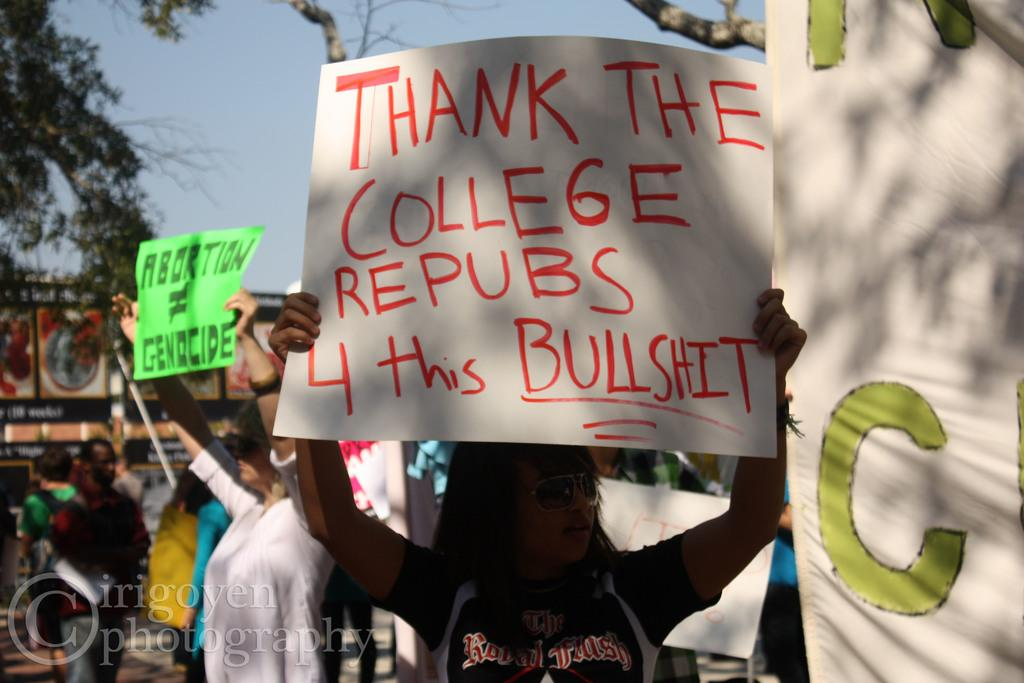How many people are in the image? There is a group of people in the image, but the exact number cannot be determined from the provided facts. What are some people doing in the image? Some people are holding placards in their hands. What can be seen in the background of the image? There are trees in the background of the image. What type of frame is holding the fish in the image? There is no frame or fish present in the image; it features a group of people holding placards and trees in the background. 